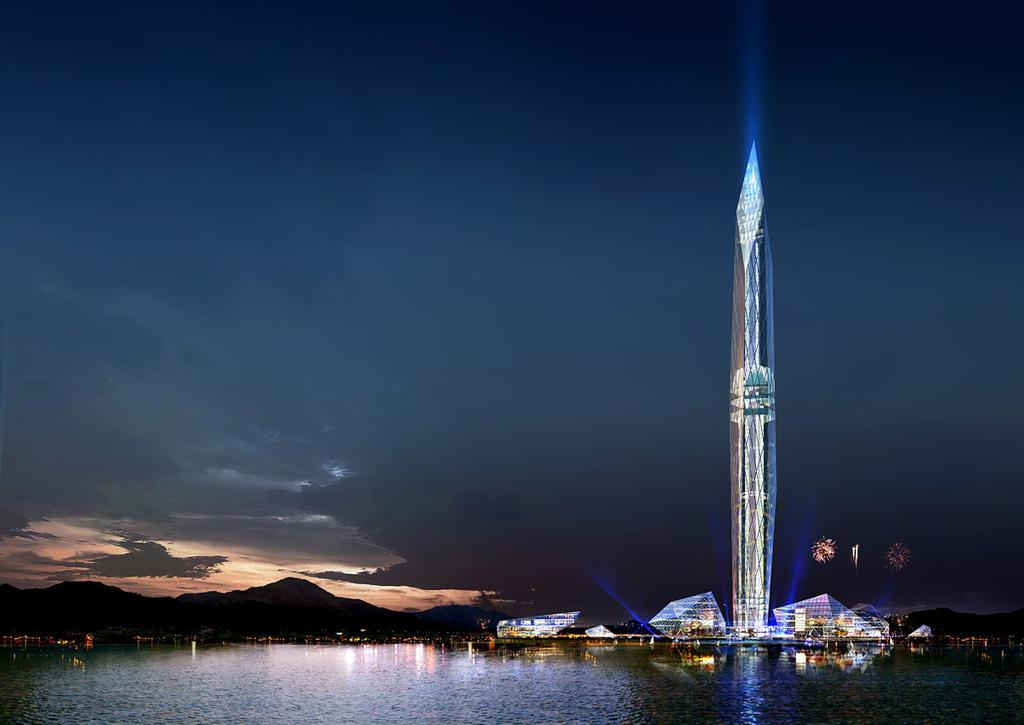What is the primary element in the image? The image consists of water. What structures can be seen in the front of the image? There are buildings in the front of the image, including a skyscraper. What type of natural feature is visible in the background of the image? There are mountains in the background of the image. What is visible in the sky at the top of the image? There are clouds in the sky at the top of the image. What grade of attraction is this image representing? The image does not represent an attraction or a grade; it is a scene with water, buildings, mountains, and clouds. 